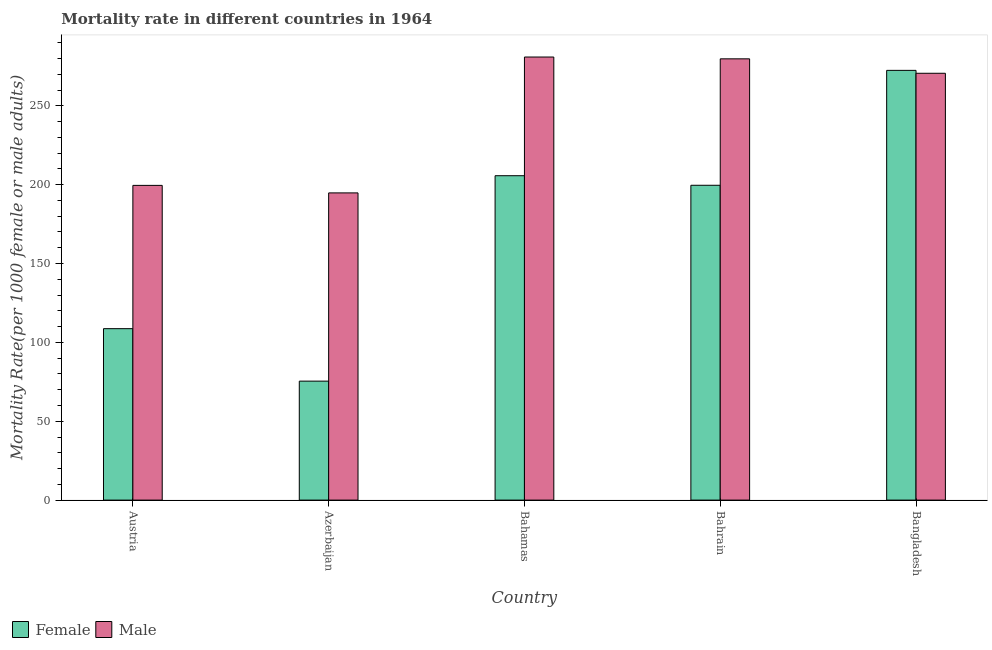How many bars are there on the 2nd tick from the left?
Ensure brevity in your answer.  2. How many bars are there on the 2nd tick from the right?
Your answer should be very brief. 2. What is the label of the 5th group of bars from the left?
Your answer should be compact. Bangladesh. What is the male mortality rate in Bahrain?
Ensure brevity in your answer.  279.78. Across all countries, what is the maximum male mortality rate?
Ensure brevity in your answer.  280.92. Across all countries, what is the minimum female mortality rate?
Your answer should be very brief. 75.43. In which country was the male mortality rate maximum?
Ensure brevity in your answer.  Bahamas. In which country was the male mortality rate minimum?
Provide a short and direct response. Azerbaijan. What is the total female mortality rate in the graph?
Your answer should be compact. 861.88. What is the difference between the male mortality rate in Azerbaijan and that in Bahrain?
Offer a very short reply. -85.01. What is the difference between the female mortality rate in Bangladesh and the male mortality rate in Azerbaijan?
Keep it short and to the point. 77.69. What is the average female mortality rate per country?
Make the answer very short. 172.38. What is the difference between the male mortality rate and female mortality rate in Bangladesh?
Offer a terse response. -1.85. What is the ratio of the male mortality rate in Austria to that in Bahamas?
Make the answer very short. 0.71. What is the difference between the highest and the second highest male mortality rate?
Keep it short and to the point. 1.14. What is the difference between the highest and the lowest female mortality rate?
Provide a short and direct response. 197.04. In how many countries, is the female mortality rate greater than the average female mortality rate taken over all countries?
Make the answer very short. 3. What does the 2nd bar from the left in Bahamas represents?
Offer a terse response. Male. How many bars are there?
Your response must be concise. 10. Are the values on the major ticks of Y-axis written in scientific E-notation?
Give a very brief answer. No. Does the graph contain grids?
Make the answer very short. No. Where does the legend appear in the graph?
Keep it short and to the point. Bottom left. How many legend labels are there?
Your answer should be compact. 2. How are the legend labels stacked?
Ensure brevity in your answer.  Horizontal. What is the title of the graph?
Ensure brevity in your answer.  Mortality rate in different countries in 1964. What is the label or title of the Y-axis?
Provide a succinct answer. Mortality Rate(per 1000 female or male adults). What is the Mortality Rate(per 1000 female or male adults) in Female in Austria?
Provide a succinct answer. 108.69. What is the Mortality Rate(per 1000 female or male adults) in Male in Austria?
Your answer should be very brief. 199.55. What is the Mortality Rate(per 1000 female or male adults) of Female in Azerbaijan?
Your answer should be very brief. 75.43. What is the Mortality Rate(per 1000 female or male adults) in Male in Azerbaijan?
Your answer should be compact. 194.78. What is the Mortality Rate(per 1000 female or male adults) in Female in Bahamas?
Offer a very short reply. 205.67. What is the Mortality Rate(per 1000 female or male adults) of Male in Bahamas?
Offer a terse response. 280.92. What is the Mortality Rate(per 1000 female or male adults) of Female in Bahrain?
Keep it short and to the point. 199.61. What is the Mortality Rate(per 1000 female or male adults) in Male in Bahrain?
Keep it short and to the point. 279.78. What is the Mortality Rate(per 1000 female or male adults) in Female in Bangladesh?
Provide a succinct answer. 272.47. What is the Mortality Rate(per 1000 female or male adults) in Male in Bangladesh?
Keep it short and to the point. 270.62. Across all countries, what is the maximum Mortality Rate(per 1000 female or male adults) of Female?
Offer a very short reply. 272.47. Across all countries, what is the maximum Mortality Rate(per 1000 female or male adults) in Male?
Your response must be concise. 280.92. Across all countries, what is the minimum Mortality Rate(per 1000 female or male adults) of Female?
Your response must be concise. 75.43. Across all countries, what is the minimum Mortality Rate(per 1000 female or male adults) of Male?
Offer a very short reply. 194.78. What is the total Mortality Rate(per 1000 female or male adults) in Female in the graph?
Your answer should be compact. 861.88. What is the total Mortality Rate(per 1000 female or male adults) of Male in the graph?
Offer a terse response. 1225.65. What is the difference between the Mortality Rate(per 1000 female or male adults) of Female in Austria and that in Azerbaijan?
Your answer should be very brief. 33.26. What is the difference between the Mortality Rate(per 1000 female or male adults) in Male in Austria and that in Azerbaijan?
Keep it short and to the point. 4.77. What is the difference between the Mortality Rate(per 1000 female or male adults) of Female in Austria and that in Bahamas?
Make the answer very short. -96.98. What is the difference between the Mortality Rate(per 1000 female or male adults) of Male in Austria and that in Bahamas?
Your answer should be very brief. -81.38. What is the difference between the Mortality Rate(per 1000 female or male adults) in Female in Austria and that in Bahrain?
Provide a short and direct response. -90.92. What is the difference between the Mortality Rate(per 1000 female or male adults) of Male in Austria and that in Bahrain?
Make the answer very short. -80.23. What is the difference between the Mortality Rate(per 1000 female or male adults) of Female in Austria and that in Bangladesh?
Your response must be concise. -163.77. What is the difference between the Mortality Rate(per 1000 female or male adults) in Male in Austria and that in Bangladesh?
Offer a very short reply. -71.08. What is the difference between the Mortality Rate(per 1000 female or male adults) of Female in Azerbaijan and that in Bahamas?
Offer a very short reply. -130.24. What is the difference between the Mortality Rate(per 1000 female or male adults) of Male in Azerbaijan and that in Bahamas?
Your answer should be compact. -86.15. What is the difference between the Mortality Rate(per 1000 female or male adults) of Female in Azerbaijan and that in Bahrain?
Offer a very short reply. -124.18. What is the difference between the Mortality Rate(per 1000 female or male adults) in Male in Azerbaijan and that in Bahrain?
Provide a succinct answer. -85.01. What is the difference between the Mortality Rate(per 1000 female or male adults) of Female in Azerbaijan and that in Bangladesh?
Your answer should be very brief. -197.04. What is the difference between the Mortality Rate(per 1000 female or male adults) in Male in Azerbaijan and that in Bangladesh?
Your answer should be very brief. -75.85. What is the difference between the Mortality Rate(per 1000 female or male adults) of Female in Bahamas and that in Bahrain?
Ensure brevity in your answer.  6.06. What is the difference between the Mortality Rate(per 1000 female or male adults) of Male in Bahamas and that in Bahrain?
Your answer should be very brief. 1.14. What is the difference between the Mortality Rate(per 1000 female or male adults) in Female in Bahamas and that in Bangladesh?
Your response must be concise. -66.8. What is the difference between the Mortality Rate(per 1000 female or male adults) of Female in Bahrain and that in Bangladesh?
Make the answer very short. -72.86. What is the difference between the Mortality Rate(per 1000 female or male adults) of Male in Bahrain and that in Bangladesh?
Provide a succinct answer. 9.16. What is the difference between the Mortality Rate(per 1000 female or male adults) in Female in Austria and the Mortality Rate(per 1000 female or male adults) in Male in Azerbaijan?
Make the answer very short. -86.08. What is the difference between the Mortality Rate(per 1000 female or male adults) in Female in Austria and the Mortality Rate(per 1000 female or male adults) in Male in Bahamas?
Your answer should be compact. -172.23. What is the difference between the Mortality Rate(per 1000 female or male adults) of Female in Austria and the Mortality Rate(per 1000 female or male adults) of Male in Bahrain?
Offer a terse response. -171.09. What is the difference between the Mortality Rate(per 1000 female or male adults) of Female in Austria and the Mortality Rate(per 1000 female or male adults) of Male in Bangladesh?
Ensure brevity in your answer.  -161.93. What is the difference between the Mortality Rate(per 1000 female or male adults) in Female in Azerbaijan and the Mortality Rate(per 1000 female or male adults) in Male in Bahamas?
Your response must be concise. -205.49. What is the difference between the Mortality Rate(per 1000 female or male adults) in Female in Azerbaijan and the Mortality Rate(per 1000 female or male adults) in Male in Bahrain?
Your response must be concise. -204.35. What is the difference between the Mortality Rate(per 1000 female or male adults) in Female in Azerbaijan and the Mortality Rate(per 1000 female or male adults) in Male in Bangladesh?
Your answer should be compact. -195.19. What is the difference between the Mortality Rate(per 1000 female or male adults) of Female in Bahamas and the Mortality Rate(per 1000 female or male adults) of Male in Bahrain?
Keep it short and to the point. -74.11. What is the difference between the Mortality Rate(per 1000 female or male adults) in Female in Bahamas and the Mortality Rate(per 1000 female or male adults) in Male in Bangladesh?
Provide a short and direct response. -64.95. What is the difference between the Mortality Rate(per 1000 female or male adults) of Female in Bahrain and the Mortality Rate(per 1000 female or male adults) of Male in Bangladesh?
Your answer should be compact. -71.01. What is the average Mortality Rate(per 1000 female or male adults) in Female per country?
Your response must be concise. 172.38. What is the average Mortality Rate(per 1000 female or male adults) in Male per country?
Give a very brief answer. 245.13. What is the difference between the Mortality Rate(per 1000 female or male adults) in Female and Mortality Rate(per 1000 female or male adults) in Male in Austria?
Your answer should be very brief. -90.85. What is the difference between the Mortality Rate(per 1000 female or male adults) of Female and Mortality Rate(per 1000 female or male adults) of Male in Azerbaijan?
Offer a very short reply. -119.34. What is the difference between the Mortality Rate(per 1000 female or male adults) of Female and Mortality Rate(per 1000 female or male adults) of Male in Bahamas?
Offer a very short reply. -75.25. What is the difference between the Mortality Rate(per 1000 female or male adults) in Female and Mortality Rate(per 1000 female or male adults) in Male in Bahrain?
Your answer should be compact. -80.17. What is the difference between the Mortality Rate(per 1000 female or male adults) of Female and Mortality Rate(per 1000 female or male adults) of Male in Bangladesh?
Provide a succinct answer. 1.84. What is the ratio of the Mortality Rate(per 1000 female or male adults) of Female in Austria to that in Azerbaijan?
Offer a very short reply. 1.44. What is the ratio of the Mortality Rate(per 1000 female or male adults) in Male in Austria to that in Azerbaijan?
Provide a succinct answer. 1.02. What is the ratio of the Mortality Rate(per 1000 female or male adults) of Female in Austria to that in Bahamas?
Your answer should be very brief. 0.53. What is the ratio of the Mortality Rate(per 1000 female or male adults) in Male in Austria to that in Bahamas?
Provide a succinct answer. 0.71. What is the ratio of the Mortality Rate(per 1000 female or male adults) in Female in Austria to that in Bahrain?
Offer a terse response. 0.54. What is the ratio of the Mortality Rate(per 1000 female or male adults) of Male in Austria to that in Bahrain?
Your response must be concise. 0.71. What is the ratio of the Mortality Rate(per 1000 female or male adults) in Female in Austria to that in Bangladesh?
Make the answer very short. 0.4. What is the ratio of the Mortality Rate(per 1000 female or male adults) in Male in Austria to that in Bangladesh?
Offer a very short reply. 0.74. What is the ratio of the Mortality Rate(per 1000 female or male adults) in Female in Azerbaijan to that in Bahamas?
Your response must be concise. 0.37. What is the ratio of the Mortality Rate(per 1000 female or male adults) in Male in Azerbaijan to that in Bahamas?
Provide a succinct answer. 0.69. What is the ratio of the Mortality Rate(per 1000 female or male adults) of Female in Azerbaijan to that in Bahrain?
Provide a short and direct response. 0.38. What is the ratio of the Mortality Rate(per 1000 female or male adults) in Male in Azerbaijan to that in Bahrain?
Provide a short and direct response. 0.7. What is the ratio of the Mortality Rate(per 1000 female or male adults) in Female in Azerbaijan to that in Bangladesh?
Ensure brevity in your answer.  0.28. What is the ratio of the Mortality Rate(per 1000 female or male adults) of Male in Azerbaijan to that in Bangladesh?
Offer a terse response. 0.72. What is the ratio of the Mortality Rate(per 1000 female or male adults) in Female in Bahamas to that in Bahrain?
Provide a succinct answer. 1.03. What is the ratio of the Mortality Rate(per 1000 female or male adults) in Female in Bahamas to that in Bangladesh?
Make the answer very short. 0.75. What is the ratio of the Mortality Rate(per 1000 female or male adults) in Male in Bahamas to that in Bangladesh?
Offer a very short reply. 1.04. What is the ratio of the Mortality Rate(per 1000 female or male adults) of Female in Bahrain to that in Bangladesh?
Offer a very short reply. 0.73. What is the ratio of the Mortality Rate(per 1000 female or male adults) of Male in Bahrain to that in Bangladesh?
Your answer should be compact. 1.03. What is the difference between the highest and the second highest Mortality Rate(per 1000 female or male adults) in Female?
Offer a very short reply. 66.8. What is the difference between the highest and the second highest Mortality Rate(per 1000 female or male adults) of Male?
Offer a terse response. 1.14. What is the difference between the highest and the lowest Mortality Rate(per 1000 female or male adults) of Female?
Provide a succinct answer. 197.04. What is the difference between the highest and the lowest Mortality Rate(per 1000 female or male adults) in Male?
Provide a succinct answer. 86.15. 